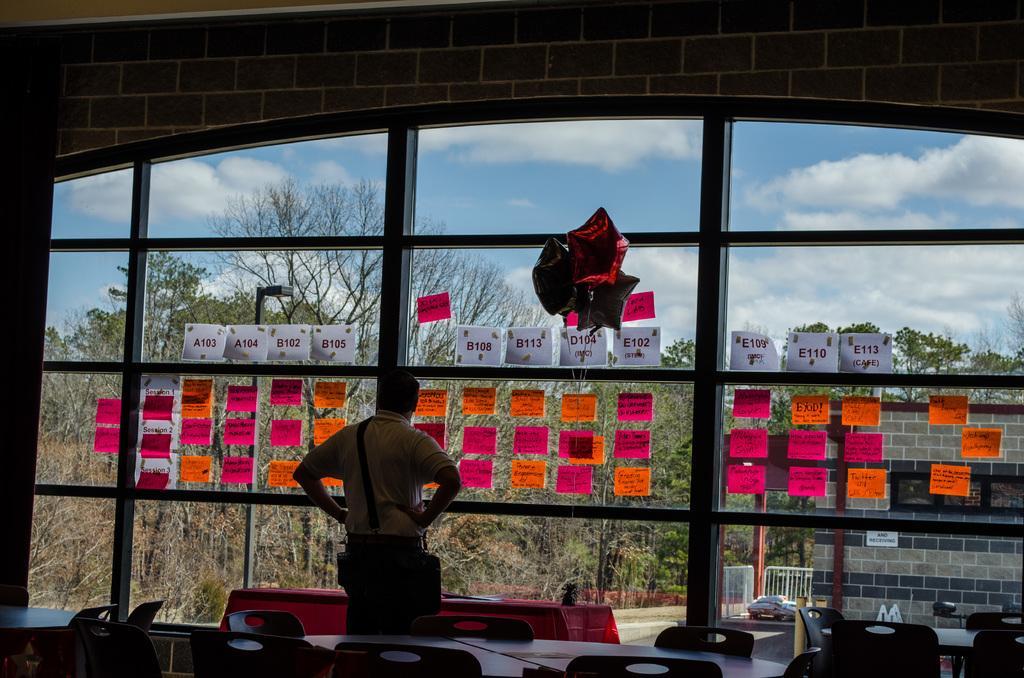In one or two sentences, can you explain what this image depicts? In this image I can see a person standing in front of the glass wall and through the wall I can see the sky , tree and a road and a vehicle and at the bottom I can see a table and a chair and there are some colorful papers attached to the wall. 